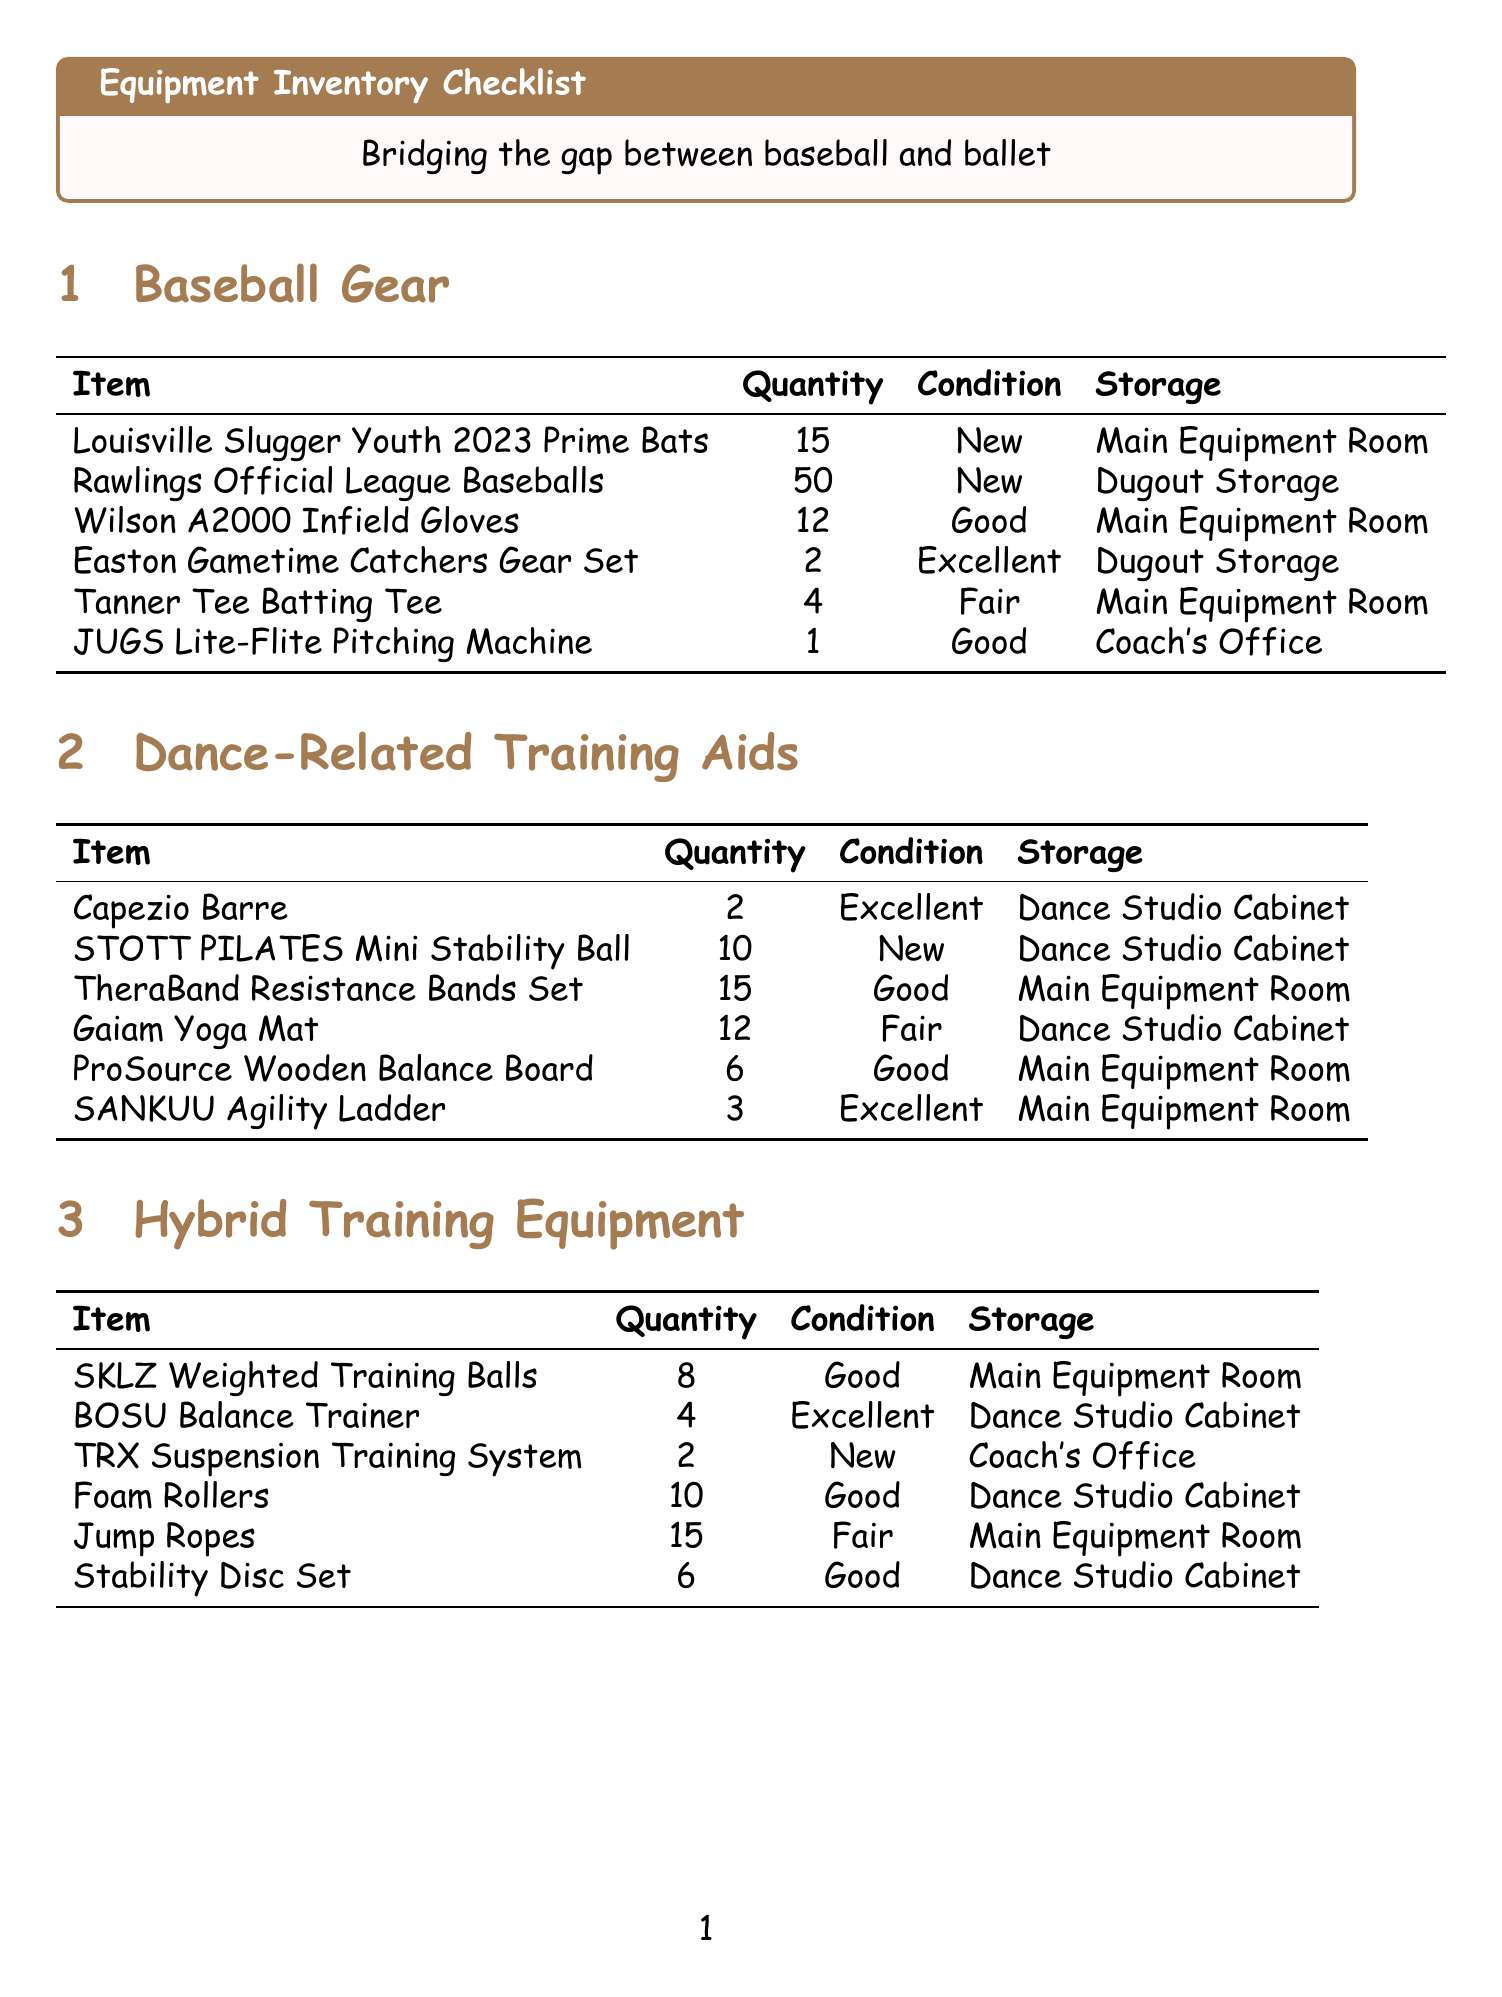What is the quantity of Louisville Slugger Youth 2023 Prime Bats? The quantity of Louisville Slugger Youth 2023 Prime Bats listed in the document is 15.
Answer: 15 What is the condition of the ProSource Wooden Balance Board? The document states that the condition of the ProSource Wooden Balance Board is Good.
Answer: Good How many dance-related training aids are stored in the Dance Studio Cabinet? There are 5 items categorized under Dance-Related Training Aids that are stored in the Dance Studio Cabinet.
Answer: 5 What is the responsible personnel's name for weekly maintenance? Sarah Thompson is responsible for weekly maintenance as mentioned in the document.
Answer: Sarah Thompson What is the total quantity of Rawlings Official League Baseballs? The total quantity of Rawlings Official League Baseballs is provided as 50 in the document.
Answer: 50 What type of maintenance is scheduled monthly for the pitching machine? The maintenance scheduled monthly for the pitching machine involves lubricating it.
Answer: Lubricate Which category contains the Tanner Tee Batting Tee? The Tanner Tee Batting Tee is categorized under Baseball Gear in the document.
Answer: Baseball Gear How many SKLZ Weighted Training Balls are available? There are 8 SKLZ Weighted Training Balls available according to the document.
Answer: 8 Which storage location holds the Gaiam Yoga Mats? The document specifies that Gaiam Yoga Mats are stored in the Dance Studio Cabinet.
Answer: Dance Studio Cabinet 